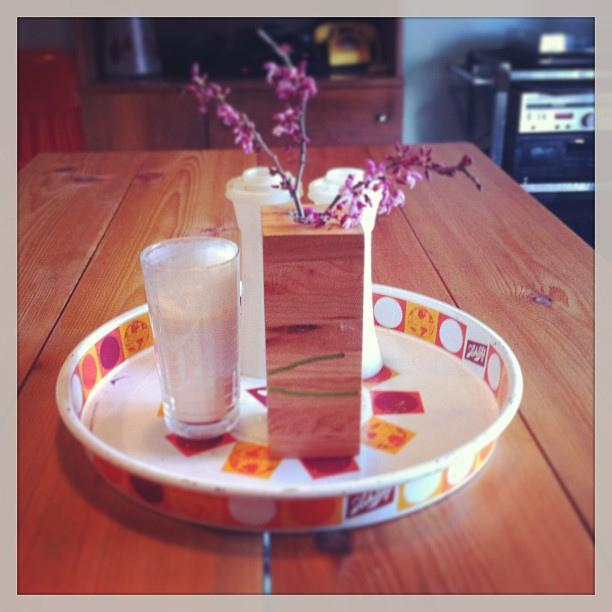Could they listen to records if they wanted to?
Short answer required. Yes. What is the design on the plate?
Quick response, please. Shapes. What color are the flowers?
Write a very short answer. Purple. 